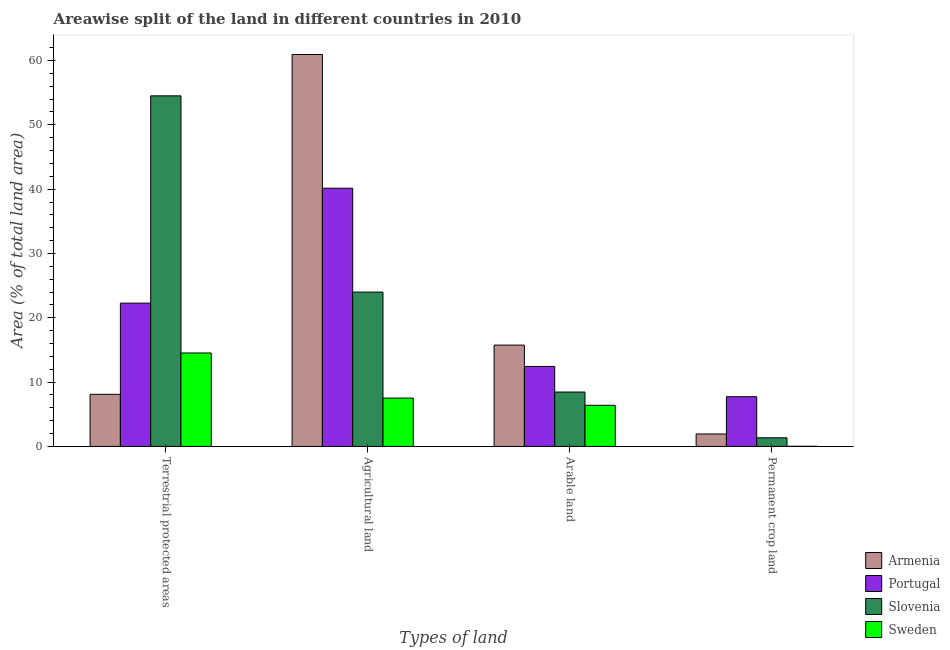Are the number of bars on each tick of the X-axis equal?
Provide a short and direct response. Yes. How many bars are there on the 2nd tick from the right?
Give a very brief answer. 4. What is the label of the 2nd group of bars from the left?
Give a very brief answer. Agricultural land. What is the percentage of area under arable land in Sweden?
Provide a short and direct response. 6.4. Across all countries, what is the maximum percentage of area under permanent crop land?
Your response must be concise. 7.73. Across all countries, what is the minimum percentage of land under terrestrial protection?
Provide a succinct answer. 8.1. In which country was the percentage of area under agricultural land maximum?
Make the answer very short. Armenia. In which country was the percentage of area under agricultural land minimum?
Offer a terse response. Sweden. What is the total percentage of area under arable land in the graph?
Offer a very short reply. 43.04. What is the difference between the percentage of area under agricultural land in Portugal and that in Slovenia?
Your answer should be very brief. 16.15. What is the difference between the percentage of area under arable land in Portugal and the percentage of land under terrestrial protection in Slovenia?
Keep it short and to the point. -42.07. What is the average percentage of area under arable land per country?
Offer a terse response. 10.76. What is the difference between the percentage of land under terrestrial protection and percentage of area under permanent crop land in Armenia?
Your answer should be very brief. 6.17. In how many countries, is the percentage of land under terrestrial protection greater than 54 %?
Your answer should be compact. 1. What is the ratio of the percentage of area under agricultural land in Slovenia to that in Armenia?
Make the answer very short. 0.39. Is the difference between the percentage of area under arable land in Armenia and Sweden greater than the difference between the percentage of area under permanent crop land in Armenia and Sweden?
Your response must be concise. Yes. What is the difference between the highest and the second highest percentage of land under terrestrial protection?
Provide a short and direct response. 32.23. What is the difference between the highest and the lowest percentage of land under terrestrial protection?
Give a very brief answer. 46.41. Is the sum of the percentage of area under arable land in Slovenia and Armenia greater than the maximum percentage of area under agricultural land across all countries?
Give a very brief answer. No. Is it the case that in every country, the sum of the percentage of area under agricultural land and percentage of area under arable land is greater than the sum of percentage of area under permanent crop land and percentage of land under terrestrial protection?
Provide a short and direct response. Yes. Is it the case that in every country, the sum of the percentage of land under terrestrial protection and percentage of area under agricultural land is greater than the percentage of area under arable land?
Make the answer very short. Yes. Are all the bars in the graph horizontal?
Your answer should be very brief. No. How many countries are there in the graph?
Ensure brevity in your answer.  4. Does the graph contain grids?
Provide a succinct answer. No. How many legend labels are there?
Your response must be concise. 4. How are the legend labels stacked?
Your answer should be compact. Vertical. What is the title of the graph?
Make the answer very short. Areawise split of the land in different countries in 2010. Does "United Kingdom" appear as one of the legend labels in the graph?
Provide a short and direct response. No. What is the label or title of the X-axis?
Provide a short and direct response. Types of land. What is the label or title of the Y-axis?
Your answer should be very brief. Area (% of total land area). What is the Area (% of total land area) in Armenia in Terrestrial protected areas?
Offer a very short reply. 8.1. What is the Area (% of total land area) of Portugal in Terrestrial protected areas?
Your answer should be compact. 22.28. What is the Area (% of total land area) in Slovenia in Terrestrial protected areas?
Give a very brief answer. 54.51. What is the Area (% of total land area) in Sweden in Terrestrial protected areas?
Provide a succinct answer. 14.53. What is the Area (% of total land area) in Armenia in Agricultural land?
Provide a short and direct response. 60.94. What is the Area (% of total land area) of Portugal in Agricultural land?
Your answer should be compact. 40.15. What is the Area (% of total land area) in Slovenia in Agricultural land?
Make the answer very short. 24. What is the Area (% of total land area) in Sweden in Agricultural land?
Give a very brief answer. 7.52. What is the Area (% of total land area) of Armenia in Arable land?
Your answer should be compact. 15.75. What is the Area (% of total land area) in Portugal in Arable land?
Ensure brevity in your answer.  12.44. What is the Area (% of total land area) in Slovenia in Arable land?
Offer a very short reply. 8.46. What is the Area (% of total land area) of Sweden in Arable land?
Provide a succinct answer. 6.4. What is the Area (% of total land area) in Armenia in Permanent crop land?
Keep it short and to the point. 1.94. What is the Area (% of total land area) of Portugal in Permanent crop land?
Offer a terse response. 7.73. What is the Area (% of total land area) of Slovenia in Permanent crop land?
Offer a very short reply. 1.34. What is the Area (% of total land area) in Sweden in Permanent crop land?
Ensure brevity in your answer.  0.02. Across all Types of land, what is the maximum Area (% of total land area) of Armenia?
Your response must be concise. 60.94. Across all Types of land, what is the maximum Area (% of total land area) in Portugal?
Offer a terse response. 40.15. Across all Types of land, what is the maximum Area (% of total land area) of Slovenia?
Your answer should be very brief. 54.51. Across all Types of land, what is the maximum Area (% of total land area) of Sweden?
Keep it short and to the point. 14.53. Across all Types of land, what is the minimum Area (% of total land area) of Armenia?
Provide a succinct answer. 1.94. Across all Types of land, what is the minimum Area (% of total land area) of Portugal?
Your answer should be compact. 7.73. Across all Types of land, what is the minimum Area (% of total land area) in Slovenia?
Offer a terse response. 1.34. Across all Types of land, what is the minimum Area (% of total land area) in Sweden?
Offer a terse response. 0.02. What is the total Area (% of total land area) of Armenia in the graph?
Your answer should be compact. 86.73. What is the total Area (% of total land area) in Portugal in the graph?
Keep it short and to the point. 82.59. What is the total Area (% of total land area) of Slovenia in the graph?
Offer a very short reply. 88.3. What is the total Area (% of total land area) in Sweden in the graph?
Make the answer very short. 28.47. What is the difference between the Area (% of total land area) in Armenia in Terrestrial protected areas and that in Agricultural land?
Offer a terse response. -52.84. What is the difference between the Area (% of total land area) in Portugal in Terrestrial protected areas and that in Agricultural land?
Your answer should be very brief. -17.87. What is the difference between the Area (% of total land area) of Slovenia in Terrestrial protected areas and that in Agricultural land?
Make the answer very short. 30.51. What is the difference between the Area (% of total land area) in Sweden in Terrestrial protected areas and that in Agricultural land?
Provide a succinct answer. 7.01. What is the difference between the Area (% of total land area) of Armenia in Terrestrial protected areas and that in Arable land?
Offer a terse response. -7.65. What is the difference between the Area (% of total land area) in Portugal in Terrestrial protected areas and that in Arable land?
Provide a short and direct response. 9.84. What is the difference between the Area (% of total land area) in Slovenia in Terrestrial protected areas and that in Arable land?
Ensure brevity in your answer.  46.05. What is the difference between the Area (% of total land area) in Sweden in Terrestrial protected areas and that in Arable land?
Ensure brevity in your answer.  8.13. What is the difference between the Area (% of total land area) in Armenia in Terrestrial protected areas and that in Permanent crop land?
Your answer should be very brief. 6.17. What is the difference between the Area (% of total land area) of Portugal in Terrestrial protected areas and that in Permanent crop land?
Your answer should be very brief. 14.55. What is the difference between the Area (% of total land area) of Slovenia in Terrestrial protected areas and that in Permanent crop land?
Offer a terse response. 53.17. What is the difference between the Area (% of total land area) in Sweden in Terrestrial protected areas and that in Permanent crop land?
Your response must be concise. 14.51. What is the difference between the Area (% of total land area) of Armenia in Agricultural land and that in Arable land?
Make the answer very short. 45.19. What is the difference between the Area (% of total land area) of Portugal in Agricultural land and that in Arable land?
Your response must be concise. 27.71. What is the difference between the Area (% of total land area) of Slovenia in Agricultural land and that in Arable land?
Make the answer very short. 15.54. What is the difference between the Area (% of total land area) of Sweden in Agricultural land and that in Arable land?
Provide a succinct answer. 1.12. What is the difference between the Area (% of total land area) of Armenia in Agricultural land and that in Permanent crop land?
Give a very brief answer. 59.01. What is the difference between the Area (% of total land area) in Portugal in Agricultural land and that in Permanent crop land?
Offer a very short reply. 32.42. What is the difference between the Area (% of total land area) in Slovenia in Agricultural land and that in Permanent crop land?
Provide a short and direct response. 22.66. What is the difference between the Area (% of total land area) in Sweden in Agricultural land and that in Permanent crop land?
Provide a succinct answer. 7.5. What is the difference between the Area (% of total land area) of Armenia in Arable land and that in Permanent crop land?
Offer a very short reply. 13.82. What is the difference between the Area (% of total land area) of Portugal in Arable land and that in Permanent crop land?
Your response must be concise. 4.71. What is the difference between the Area (% of total land area) of Slovenia in Arable land and that in Permanent crop land?
Give a very brief answer. 7.12. What is the difference between the Area (% of total land area) in Sweden in Arable land and that in Permanent crop land?
Make the answer very short. 6.38. What is the difference between the Area (% of total land area) of Armenia in Terrestrial protected areas and the Area (% of total land area) of Portugal in Agricultural land?
Your answer should be compact. -32.04. What is the difference between the Area (% of total land area) of Armenia in Terrestrial protected areas and the Area (% of total land area) of Slovenia in Agricultural land?
Offer a terse response. -15.89. What is the difference between the Area (% of total land area) in Armenia in Terrestrial protected areas and the Area (% of total land area) in Sweden in Agricultural land?
Your answer should be compact. 0.58. What is the difference between the Area (% of total land area) of Portugal in Terrestrial protected areas and the Area (% of total land area) of Slovenia in Agricultural land?
Provide a short and direct response. -1.72. What is the difference between the Area (% of total land area) of Portugal in Terrestrial protected areas and the Area (% of total land area) of Sweden in Agricultural land?
Keep it short and to the point. 14.76. What is the difference between the Area (% of total land area) in Slovenia in Terrestrial protected areas and the Area (% of total land area) in Sweden in Agricultural land?
Make the answer very short. 46.99. What is the difference between the Area (% of total land area) of Armenia in Terrestrial protected areas and the Area (% of total land area) of Portugal in Arable land?
Your answer should be compact. -4.33. What is the difference between the Area (% of total land area) in Armenia in Terrestrial protected areas and the Area (% of total land area) in Slovenia in Arable land?
Your answer should be compact. -0.35. What is the difference between the Area (% of total land area) of Armenia in Terrestrial protected areas and the Area (% of total land area) of Sweden in Arable land?
Make the answer very short. 1.71. What is the difference between the Area (% of total land area) of Portugal in Terrestrial protected areas and the Area (% of total land area) of Slovenia in Arable land?
Offer a terse response. 13.82. What is the difference between the Area (% of total land area) of Portugal in Terrestrial protected areas and the Area (% of total land area) of Sweden in Arable land?
Offer a terse response. 15.88. What is the difference between the Area (% of total land area) in Slovenia in Terrestrial protected areas and the Area (% of total land area) in Sweden in Arable land?
Give a very brief answer. 48.11. What is the difference between the Area (% of total land area) of Armenia in Terrestrial protected areas and the Area (% of total land area) of Portugal in Permanent crop land?
Offer a very short reply. 0.37. What is the difference between the Area (% of total land area) of Armenia in Terrestrial protected areas and the Area (% of total land area) of Slovenia in Permanent crop land?
Offer a very short reply. 6.76. What is the difference between the Area (% of total land area) of Armenia in Terrestrial protected areas and the Area (% of total land area) of Sweden in Permanent crop land?
Ensure brevity in your answer.  8.08. What is the difference between the Area (% of total land area) of Portugal in Terrestrial protected areas and the Area (% of total land area) of Slovenia in Permanent crop land?
Provide a short and direct response. 20.94. What is the difference between the Area (% of total land area) of Portugal in Terrestrial protected areas and the Area (% of total land area) of Sweden in Permanent crop land?
Make the answer very short. 22.26. What is the difference between the Area (% of total land area) of Slovenia in Terrestrial protected areas and the Area (% of total land area) of Sweden in Permanent crop land?
Your response must be concise. 54.49. What is the difference between the Area (% of total land area) in Armenia in Agricultural land and the Area (% of total land area) in Portugal in Arable land?
Your answer should be very brief. 48.51. What is the difference between the Area (% of total land area) of Armenia in Agricultural land and the Area (% of total land area) of Slovenia in Arable land?
Your answer should be very brief. 52.49. What is the difference between the Area (% of total land area) of Armenia in Agricultural land and the Area (% of total land area) of Sweden in Arable land?
Your answer should be very brief. 54.54. What is the difference between the Area (% of total land area) of Portugal in Agricultural land and the Area (% of total land area) of Slovenia in Arable land?
Offer a terse response. 31.69. What is the difference between the Area (% of total land area) in Portugal in Agricultural land and the Area (% of total land area) in Sweden in Arable land?
Your answer should be compact. 33.75. What is the difference between the Area (% of total land area) of Slovenia in Agricultural land and the Area (% of total land area) of Sweden in Arable land?
Provide a succinct answer. 17.6. What is the difference between the Area (% of total land area) in Armenia in Agricultural land and the Area (% of total land area) in Portugal in Permanent crop land?
Offer a terse response. 53.21. What is the difference between the Area (% of total land area) in Armenia in Agricultural land and the Area (% of total land area) in Slovenia in Permanent crop land?
Give a very brief answer. 59.6. What is the difference between the Area (% of total land area) of Armenia in Agricultural land and the Area (% of total land area) of Sweden in Permanent crop land?
Your response must be concise. 60.92. What is the difference between the Area (% of total land area) of Portugal in Agricultural land and the Area (% of total land area) of Slovenia in Permanent crop land?
Your answer should be very brief. 38.81. What is the difference between the Area (% of total land area) of Portugal in Agricultural land and the Area (% of total land area) of Sweden in Permanent crop land?
Ensure brevity in your answer.  40.12. What is the difference between the Area (% of total land area) of Slovenia in Agricultural land and the Area (% of total land area) of Sweden in Permanent crop land?
Your answer should be compact. 23.98. What is the difference between the Area (% of total land area) of Armenia in Arable land and the Area (% of total land area) of Portugal in Permanent crop land?
Provide a short and direct response. 8.02. What is the difference between the Area (% of total land area) in Armenia in Arable land and the Area (% of total land area) in Slovenia in Permanent crop land?
Your answer should be very brief. 14.41. What is the difference between the Area (% of total land area) of Armenia in Arable land and the Area (% of total land area) of Sweden in Permanent crop land?
Offer a very short reply. 15.73. What is the difference between the Area (% of total land area) of Portugal in Arable land and the Area (% of total land area) of Slovenia in Permanent crop land?
Ensure brevity in your answer.  11.1. What is the difference between the Area (% of total land area) in Portugal in Arable land and the Area (% of total land area) in Sweden in Permanent crop land?
Keep it short and to the point. 12.41. What is the difference between the Area (% of total land area) in Slovenia in Arable land and the Area (% of total land area) in Sweden in Permanent crop land?
Your answer should be compact. 8.43. What is the average Area (% of total land area) of Armenia per Types of land?
Offer a very short reply. 21.68. What is the average Area (% of total land area) of Portugal per Types of land?
Provide a short and direct response. 20.65. What is the average Area (% of total land area) of Slovenia per Types of land?
Offer a terse response. 22.08. What is the average Area (% of total land area) in Sweden per Types of land?
Keep it short and to the point. 7.12. What is the difference between the Area (% of total land area) in Armenia and Area (% of total land area) in Portugal in Terrestrial protected areas?
Your answer should be very brief. -14.18. What is the difference between the Area (% of total land area) in Armenia and Area (% of total land area) in Slovenia in Terrestrial protected areas?
Offer a terse response. -46.41. What is the difference between the Area (% of total land area) of Armenia and Area (% of total land area) of Sweden in Terrestrial protected areas?
Provide a short and direct response. -6.43. What is the difference between the Area (% of total land area) in Portugal and Area (% of total land area) in Slovenia in Terrestrial protected areas?
Your response must be concise. -32.23. What is the difference between the Area (% of total land area) of Portugal and Area (% of total land area) of Sweden in Terrestrial protected areas?
Offer a terse response. 7.75. What is the difference between the Area (% of total land area) in Slovenia and Area (% of total land area) in Sweden in Terrestrial protected areas?
Offer a very short reply. 39.98. What is the difference between the Area (% of total land area) of Armenia and Area (% of total land area) of Portugal in Agricultural land?
Your answer should be very brief. 20.8. What is the difference between the Area (% of total land area) in Armenia and Area (% of total land area) in Slovenia in Agricultural land?
Ensure brevity in your answer.  36.94. What is the difference between the Area (% of total land area) of Armenia and Area (% of total land area) of Sweden in Agricultural land?
Your answer should be very brief. 53.42. What is the difference between the Area (% of total land area) in Portugal and Area (% of total land area) in Slovenia in Agricultural land?
Your response must be concise. 16.15. What is the difference between the Area (% of total land area) of Portugal and Area (% of total land area) of Sweden in Agricultural land?
Offer a very short reply. 32.63. What is the difference between the Area (% of total land area) in Slovenia and Area (% of total land area) in Sweden in Agricultural land?
Your answer should be compact. 16.48. What is the difference between the Area (% of total land area) of Armenia and Area (% of total land area) of Portugal in Arable land?
Give a very brief answer. 3.32. What is the difference between the Area (% of total land area) of Armenia and Area (% of total land area) of Slovenia in Arable land?
Keep it short and to the point. 7.3. What is the difference between the Area (% of total land area) in Armenia and Area (% of total land area) in Sweden in Arable land?
Ensure brevity in your answer.  9.36. What is the difference between the Area (% of total land area) of Portugal and Area (% of total land area) of Slovenia in Arable land?
Make the answer very short. 3.98. What is the difference between the Area (% of total land area) of Portugal and Area (% of total land area) of Sweden in Arable land?
Provide a short and direct response. 6.04. What is the difference between the Area (% of total land area) of Slovenia and Area (% of total land area) of Sweden in Arable land?
Your response must be concise. 2.06. What is the difference between the Area (% of total land area) of Armenia and Area (% of total land area) of Portugal in Permanent crop land?
Your answer should be very brief. -5.79. What is the difference between the Area (% of total land area) of Armenia and Area (% of total land area) of Slovenia in Permanent crop land?
Give a very brief answer. 0.59. What is the difference between the Area (% of total land area) in Armenia and Area (% of total land area) in Sweden in Permanent crop land?
Your answer should be compact. 1.91. What is the difference between the Area (% of total land area) in Portugal and Area (% of total land area) in Slovenia in Permanent crop land?
Offer a terse response. 6.39. What is the difference between the Area (% of total land area) of Portugal and Area (% of total land area) of Sweden in Permanent crop land?
Your answer should be very brief. 7.71. What is the difference between the Area (% of total land area) of Slovenia and Area (% of total land area) of Sweden in Permanent crop land?
Your answer should be very brief. 1.32. What is the ratio of the Area (% of total land area) of Armenia in Terrestrial protected areas to that in Agricultural land?
Keep it short and to the point. 0.13. What is the ratio of the Area (% of total land area) of Portugal in Terrestrial protected areas to that in Agricultural land?
Your answer should be compact. 0.56. What is the ratio of the Area (% of total land area) in Slovenia in Terrestrial protected areas to that in Agricultural land?
Offer a very short reply. 2.27. What is the ratio of the Area (% of total land area) of Sweden in Terrestrial protected areas to that in Agricultural land?
Your response must be concise. 1.93. What is the ratio of the Area (% of total land area) of Armenia in Terrestrial protected areas to that in Arable land?
Offer a terse response. 0.51. What is the ratio of the Area (% of total land area) of Portugal in Terrestrial protected areas to that in Arable land?
Give a very brief answer. 1.79. What is the ratio of the Area (% of total land area) in Slovenia in Terrestrial protected areas to that in Arable land?
Offer a terse response. 6.45. What is the ratio of the Area (% of total land area) in Sweden in Terrestrial protected areas to that in Arable land?
Your answer should be compact. 2.27. What is the ratio of the Area (% of total land area) of Armenia in Terrestrial protected areas to that in Permanent crop land?
Your answer should be very brief. 4.19. What is the ratio of the Area (% of total land area) in Portugal in Terrestrial protected areas to that in Permanent crop land?
Give a very brief answer. 2.88. What is the ratio of the Area (% of total land area) of Slovenia in Terrestrial protected areas to that in Permanent crop land?
Ensure brevity in your answer.  40.66. What is the ratio of the Area (% of total land area) of Sweden in Terrestrial protected areas to that in Permanent crop land?
Your answer should be compact. 662.45. What is the ratio of the Area (% of total land area) in Armenia in Agricultural land to that in Arable land?
Offer a very short reply. 3.87. What is the ratio of the Area (% of total land area) in Portugal in Agricultural land to that in Arable land?
Offer a terse response. 3.23. What is the ratio of the Area (% of total land area) in Slovenia in Agricultural land to that in Arable land?
Make the answer very short. 2.84. What is the ratio of the Area (% of total land area) in Sweden in Agricultural land to that in Arable land?
Give a very brief answer. 1.18. What is the ratio of the Area (% of total land area) in Armenia in Agricultural land to that in Permanent crop land?
Ensure brevity in your answer.  31.49. What is the ratio of the Area (% of total land area) of Portugal in Agricultural land to that in Permanent crop land?
Provide a short and direct response. 5.19. What is the ratio of the Area (% of total land area) in Slovenia in Agricultural land to that in Permanent crop land?
Offer a very short reply. 17.9. What is the ratio of the Area (% of total land area) of Sweden in Agricultural land to that in Permanent crop land?
Give a very brief answer. 342.78. What is the ratio of the Area (% of total land area) of Armenia in Arable land to that in Permanent crop land?
Make the answer very short. 8.14. What is the ratio of the Area (% of total land area) of Portugal in Arable land to that in Permanent crop land?
Your response must be concise. 1.61. What is the ratio of the Area (% of total land area) of Slovenia in Arable land to that in Permanent crop land?
Ensure brevity in your answer.  6.31. What is the ratio of the Area (% of total land area) of Sweden in Arable land to that in Permanent crop land?
Give a very brief answer. 291.67. What is the difference between the highest and the second highest Area (% of total land area) of Armenia?
Make the answer very short. 45.19. What is the difference between the highest and the second highest Area (% of total land area) of Portugal?
Make the answer very short. 17.87. What is the difference between the highest and the second highest Area (% of total land area) of Slovenia?
Make the answer very short. 30.51. What is the difference between the highest and the second highest Area (% of total land area) in Sweden?
Give a very brief answer. 7.01. What is the difference between the highest and the lowest Area (% of total land area) of Armenia?
Offer a terse response. 59.01. What is the difference between the highest and the lowest Area (% of total land area) in Portugal?
Give a very brief answer. 32.42. What is the difference between the highest and the lowest Area (% of total land area) in Slovenia?
Make the answer very short. 53.17. What is the difference between the highest and the lowest Area (% of total land area) of Sweden?
Keep it short and to the point. 14.51. 